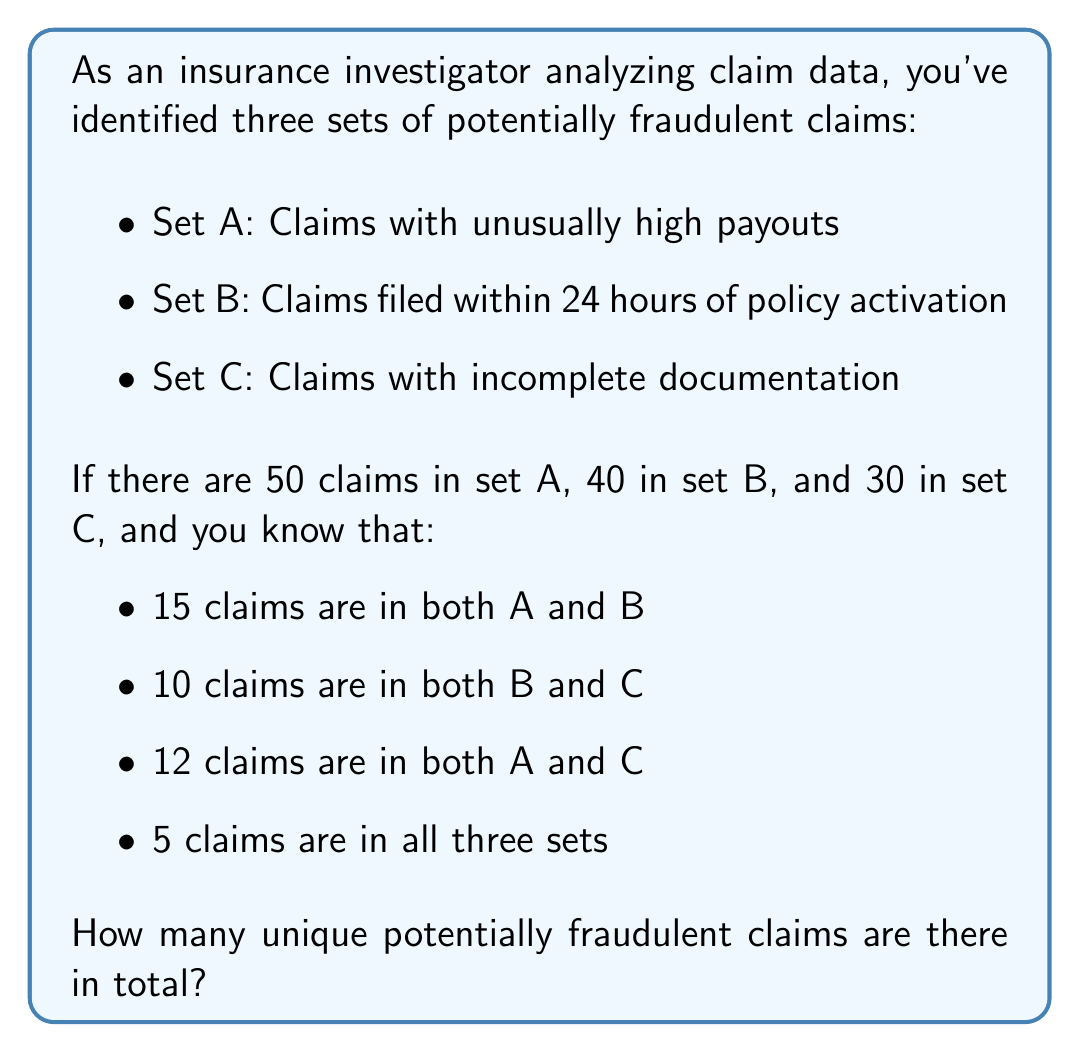Help me with this question. To solve this problem, we'll use the principle of inclusion-exclusion from set theory. Let's break it down step-by-step:

1) First, let's define our universal set U as all potentially fraudulent claims.

2) We're given:
   $|A| = 50$, $|B| = 40$, $|C| = 30$
   $|A \cap B| = 15$, $|B \cap C| = 10$, $|A \cap C| = 12$
   $|A \cap B \cap C| = 5$

3) The formula for three sets is:

   $$|U| = |A \cup B \cup C| = |A| + |B| + |C| - |A \cap B| - |B \cap C| - |A \cap C| + |A \cap B \cap C|$$

4) Let's substitute our values:

   $$|U| = 50 + 40 + 30 - 15 - 10 - 12 + 5$$

5) Now we can calculate:

   $$|U| = 120 - 37 + 5 = 88$$

Therefore, there are 88 unique potentially fraudulent claims in total.

This method ensures we don't double-count claims that appear in multiple sets, which is crucial for accurate fraud detection and investigation.
Answer: 88 unique potentially fraudulent claims 